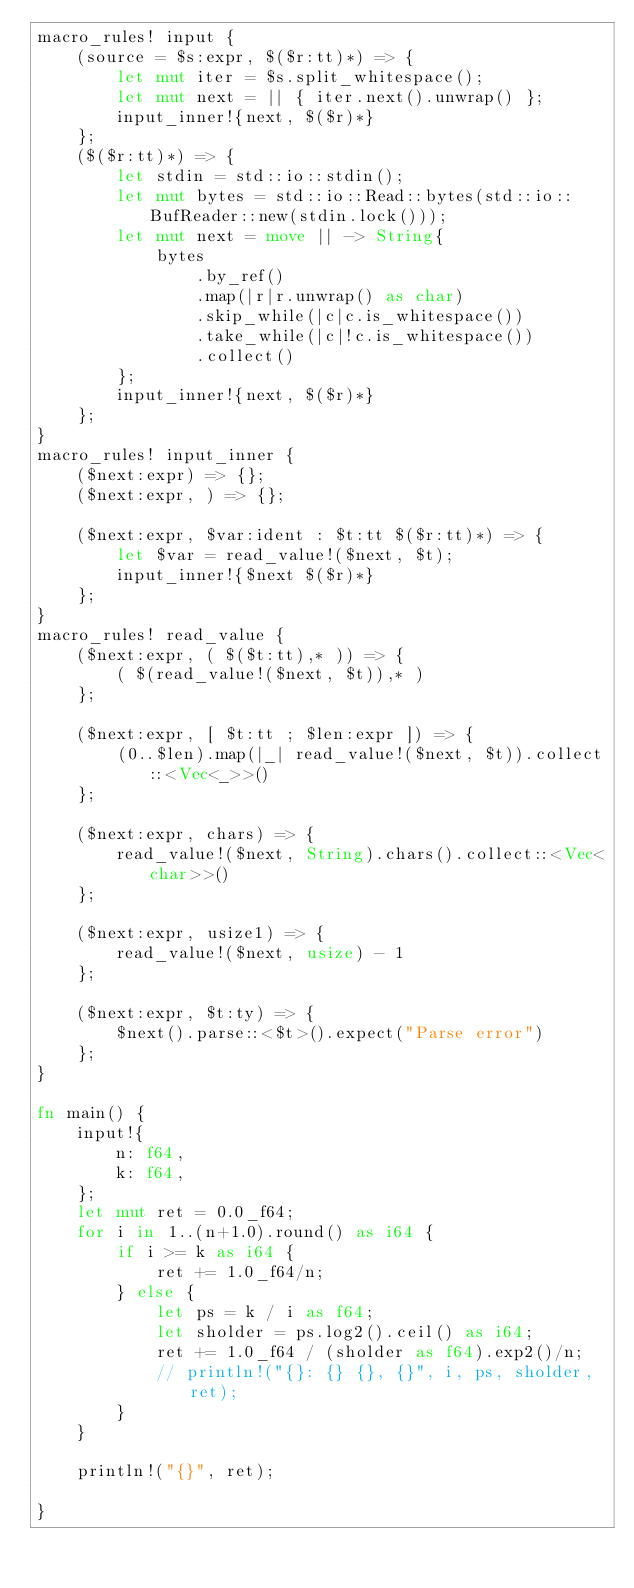<code> <loc_0><loc_0><loc_500><loc_500><_Rust_>macro_rules! input {
    (source = $s:expr, $($r:tt)*) => {
        let mut iter = $s.split_whitespace();
        let mut next = || { iter.next().unwrap() };
        input_inner!{next, $($r)*}
    };
    ($($r:tt)*) => {
        let stdin = std::io::stdin();
        let mut bytes = std::io::Read::bytes(std::io::BufReader::new(stdin.lock()));
        let mut next = move || -> String{
            bytes
                .by_ref()
                .map(|r|r.unwrap() as char)
                .skip_while(|c|c.is_whitespace())
                .take_while(|c|!c.is_whitespace())
                .collect()
        };
        input_inner!{next, $($r)*}
    };
}
macro_rules! input_inner {
    ($next:expr) => {};
    ($next:expr, ) => {};

    ($next:expr, $var:ident : $t:tt $($r:tt)*) => {
        let $var = read_value!($next, $t);
        input_inner!{$next $($r)*}
    };
}
macro_rules! read_value {
    ($next:expr, ( $($t:tt),* )) => {
        ( $(read_value!($next, $t)),* )
    };

    ($next:expr, [ $t:tt ; $len:expr ]) => {
        (0..$len).map(|_| read_value!($next, $t)).collect::<Vec<_>>()
    };

    ($next:expr, chars) => {
        read_value!($next, String).chars().collect::<Vec<char>>()
    };

    ($next:expr, usize1) => {
        read_value!($next, usize) - 1
    };

    ($next:expr, $t:ty) => {
        $next().parse::<$t>().expect("Parse error")
    };
}

fn main() {
    input!{
        n: f64,
        k: f64,
    };
    let mut ret = 0.0_f64;
    for i in 1..(n+1.0).round() as i64 {
        if i >= k as i64 {
            ret += 1.0_f64/n;
        } else {
            let ps = k / i as f64;
            let sholder = ps.log2().ceil() as i64;
            ret += 1.0_f64 / (sholder as f64).exp2()/n;
            // println!("{}: {} {}, {}", i, ps, sholder, ret);
        }
    }

    println!("{}", ret);

}

</code> 